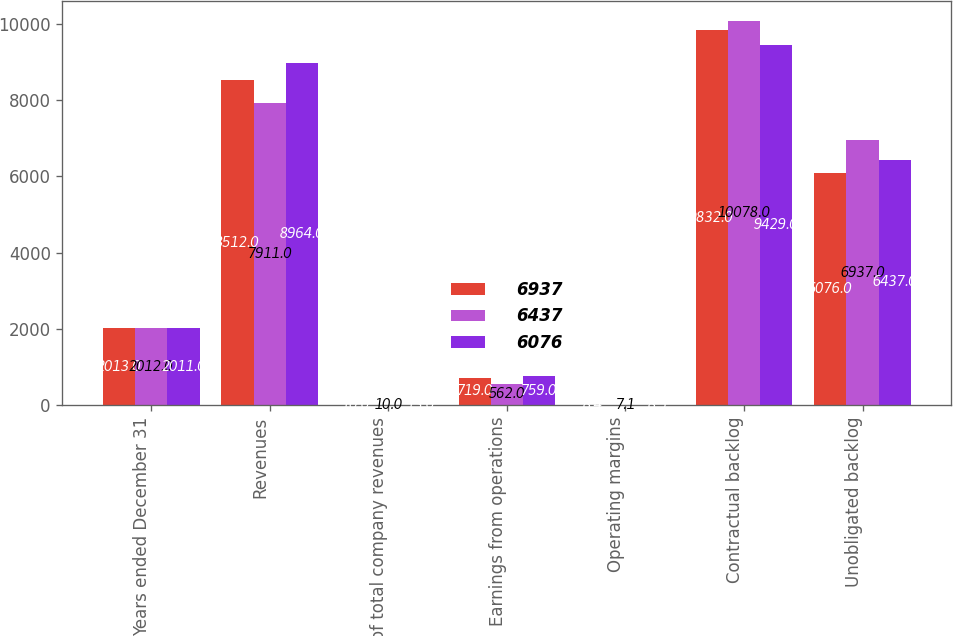<chart> <loc_0><loc_0><loc_500><loc_500><stacked_bar_chart><ecel><fcel>Years ended December 31<fcel>Revenues<fcel>of total company revenues<fcel>Earnings from operations<fcel>Operating margins<fcel>Contractual backlog<fcel>Unobligated backlog<nl><fcel>6937<fcel>2013<fcel>8512<fcel>10<fcel>719<fcel>8.4<fcel>9832<fcel>6076<nl><fcel>6437<fcel>2012<fcel>7911<fcel>10<fcel>562<fcel>7.1<fcel>10078<fcel>6937<nl><fcel>6076<fcel>2011<fcel>8964<fcel>13<fcel>759<fcel>8.5<fcel>9429<fcel>6437<nl></chart> 